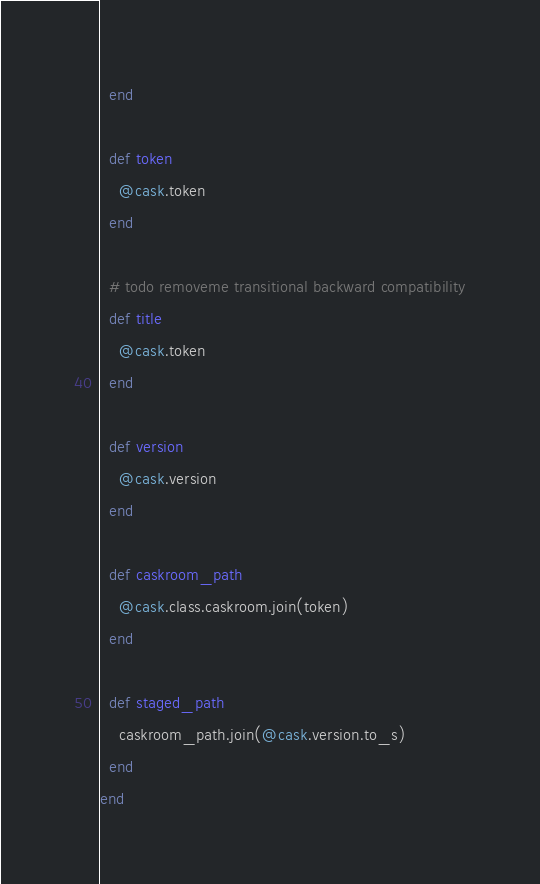Convert code to text. <code><loc_0><loc_0><loc_500><loc_500><_Ruby_>  end

  def token
    @cask.token
  end

  # todo removeme transitional backward compatibility
  def title
    @cask.token
  end

  def version
    @cask.version
  end

  def caskroom_path
    @cask.class.caskroom.join(token)
  end

  def staged_path
    caskroom_path.join(@cask.version.to_s)
  end
end
</code> 